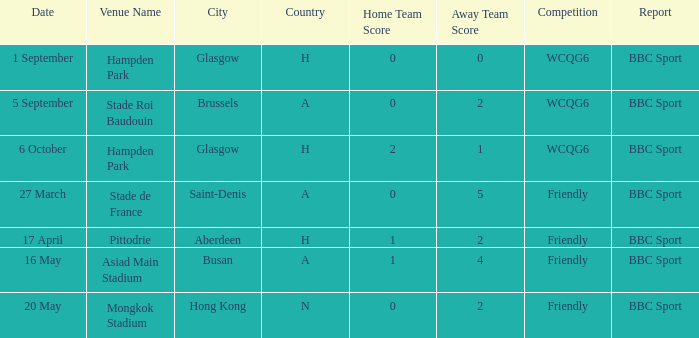Where was the game played on 20 may? Mongkok Stadium , Hong Kong (N). Help me parse the entirety of this table. {'header': ['Date', 'Venue Name', 'City', 'Country', 'Home Team Score', 'Away Team Score', 'Competition', 'Report'], 'rows': [['1 September', 'Hampden Park', 'Glasgow', 'H', '0', '0', 'WCQG6', 'BBC Sport'], ['5 September', 'Stade Roi Baudouin', 'Brussels', 'A', '0', '2', 'WCQG6', 'BBC Sport'], ['6 October', 'Hampden Park', 'Glasgow', 'H', '2', '1', 'WCQG6', 'BBC Sport'], ['27 March', 'Stade de France', 'Saint-Denis', 'A', '0', '5', 'Friendly', 'BBC Sport'], ['17 April', 'Pittodrie', 'Aberdeen', 'H', '1', '2', 'Friendly', 'BBC Sport'], ['16 May', 'Asiad Main Stadium', 'Busan', 'A', '1', '4', 'Friendly', 'BBC Sport'], ['20 May', 'Mongkok Stadium', 'Hong Kong', 'N', '0', '2', 'Friendly', 'BBC Sport']]} 